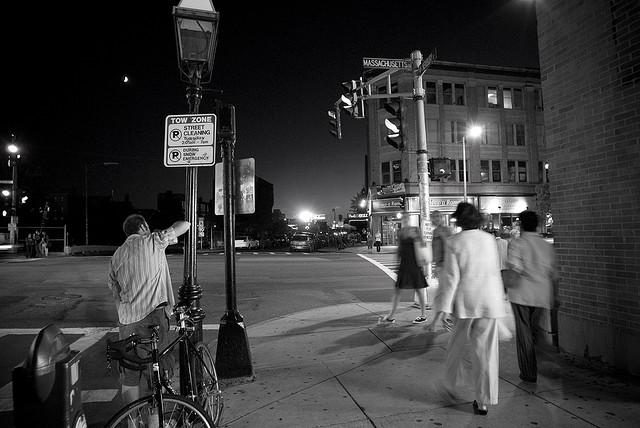What street name or intersection can be clearly seen on the corner? massachusetts 